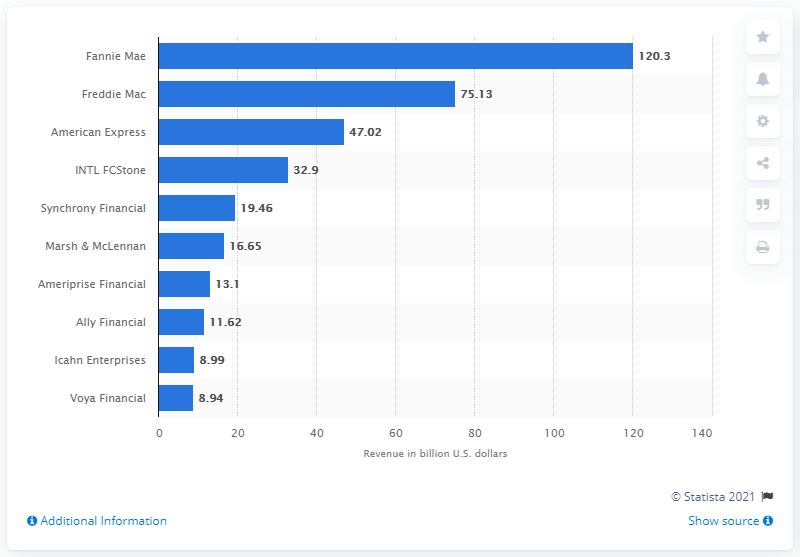Point out several critical features in this image. In 2019, Fannie Mae's revenue was 120.3 billion dollars. 